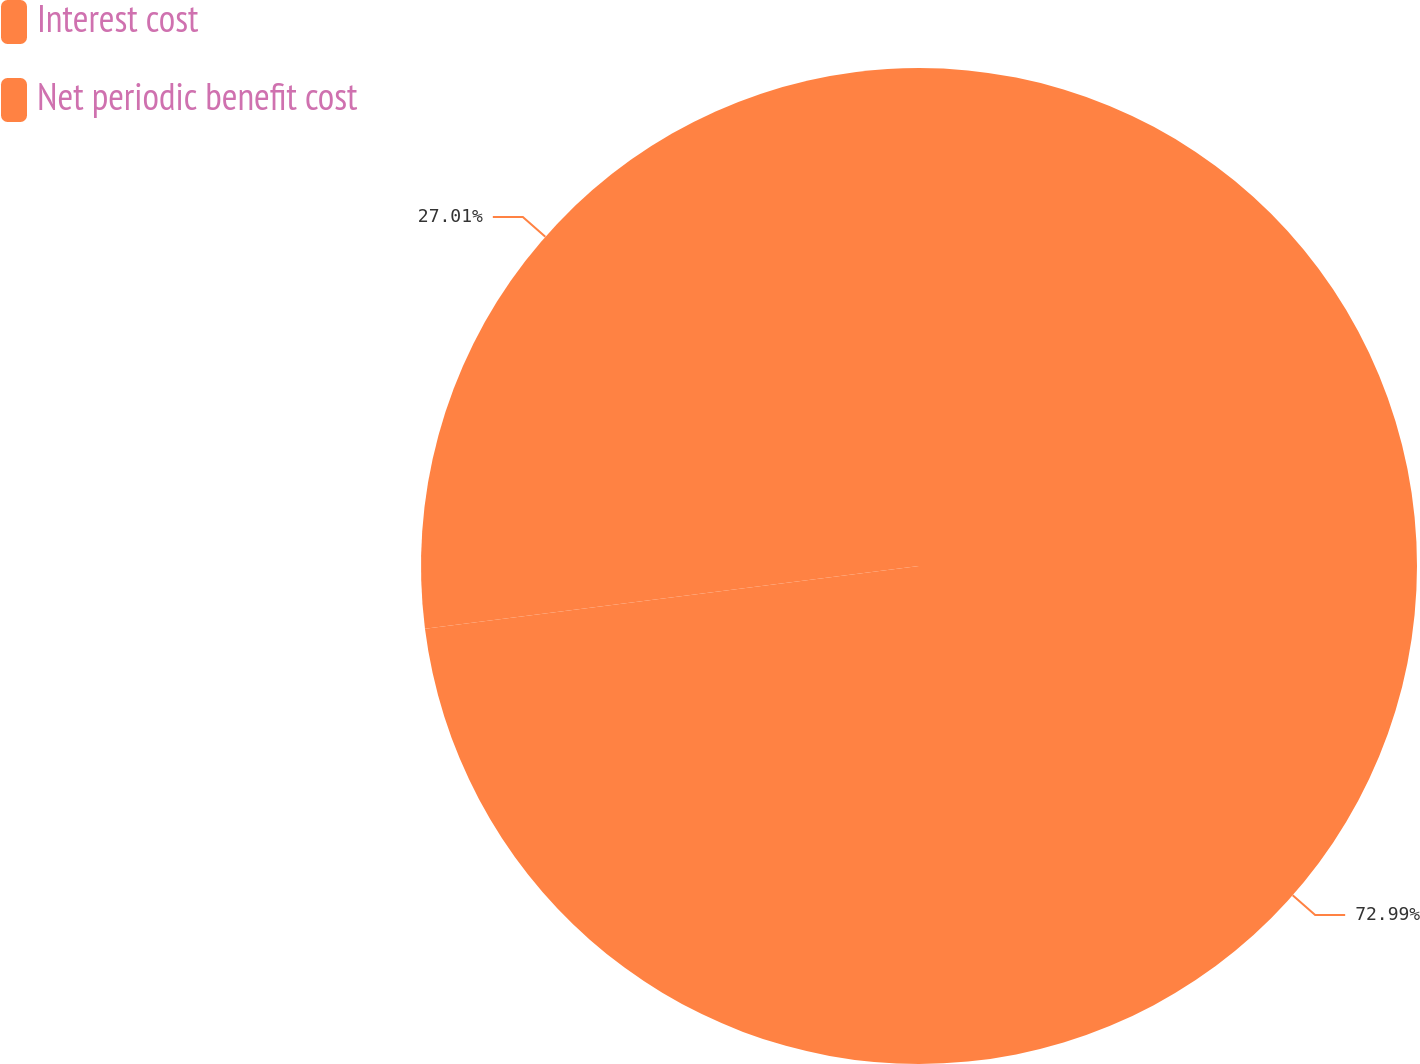<chart> <loc_0><loc_0><loc_500><loc_500><pie_chart><fcel>Interest cost<fcel>Net periodic benefit cost<nl><fcel>72.99%<fcel>27.01%<nl></chart> 